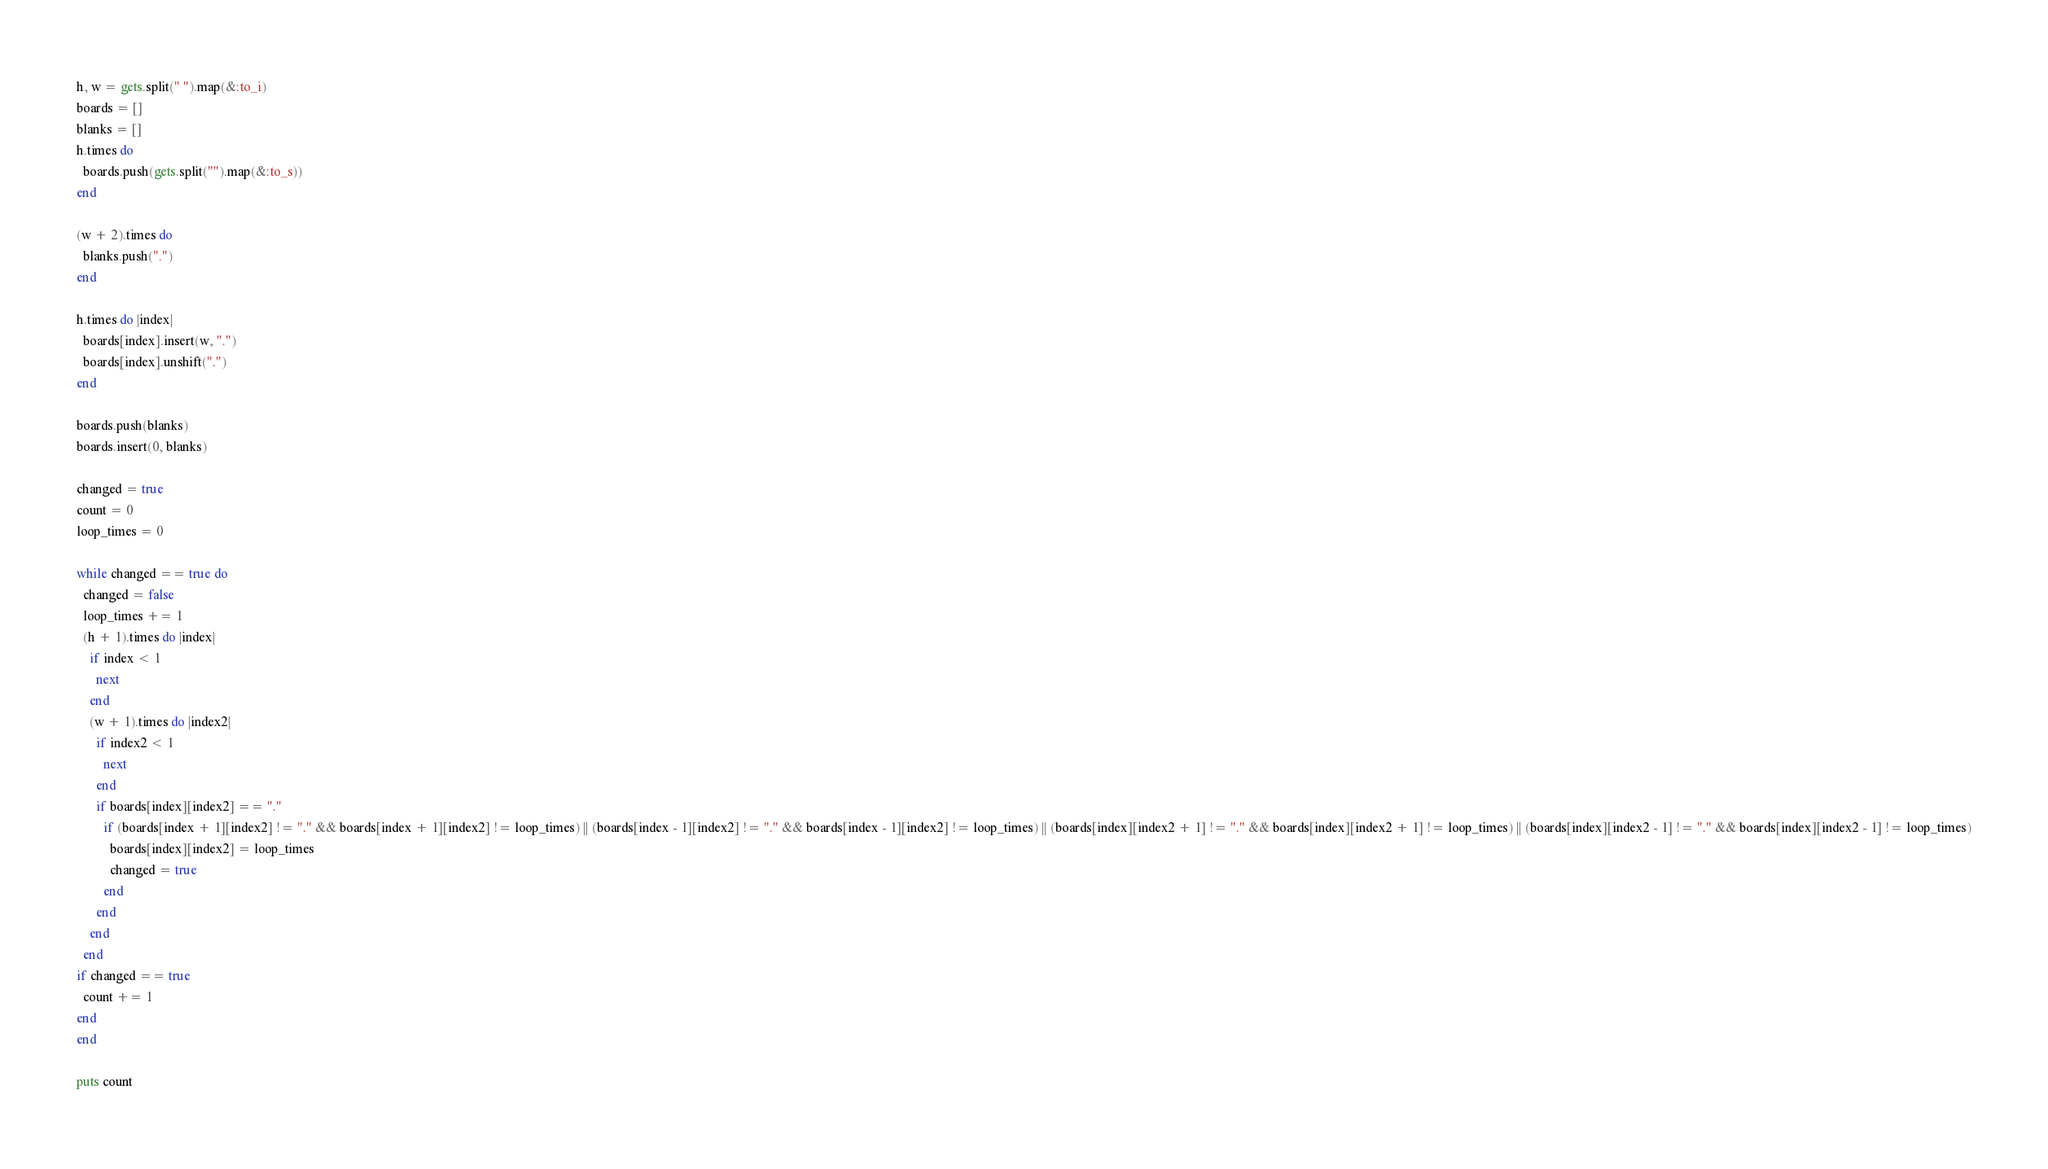<code> <loc_0><loc_0><loc_500><loc_500><_Ruby_>h, w = gets.split(" ").map(&:to_i)
boards = []
blanks = []
h.times do
  boards.push(gets.split("").map(&:to_s))
end

(w + 2).times do
  blanks.push(".")
end

h.times do |index|
  boards[index].insert(w, ".")
  boards[index].unshift(".")
end

boards.push(blanks)
boards.insert(0, blanks)

changed = true
count = 0
loop_times = 0

while changed == true do
  changed = false
  loop_times += 1
  (h + 1).times do |index|
    if index < 1
      next
    end
    (w + 1).times do |index2|
      if index2 < 1
        next
      end
      if boards[index][index2] == "."
        if (boards[index + 1][index2] != "." && boards[index + 1][index2] != loop_times) || (boards[index - 1][index2] != "." && boards[index - 1][index2] != loop_times) || (boards[index][index2 + 1] != "." && boards[index][index2 + 1] != loop_times) || (boards[index][index2 - 1] != "." && boards[index][index2 - 1] != loop_times)
          boards[index][index2] = loop_times
          changed = true
        end
      end
    end
  end
if changed == true
  count += 1
end
end

puts count </code> 